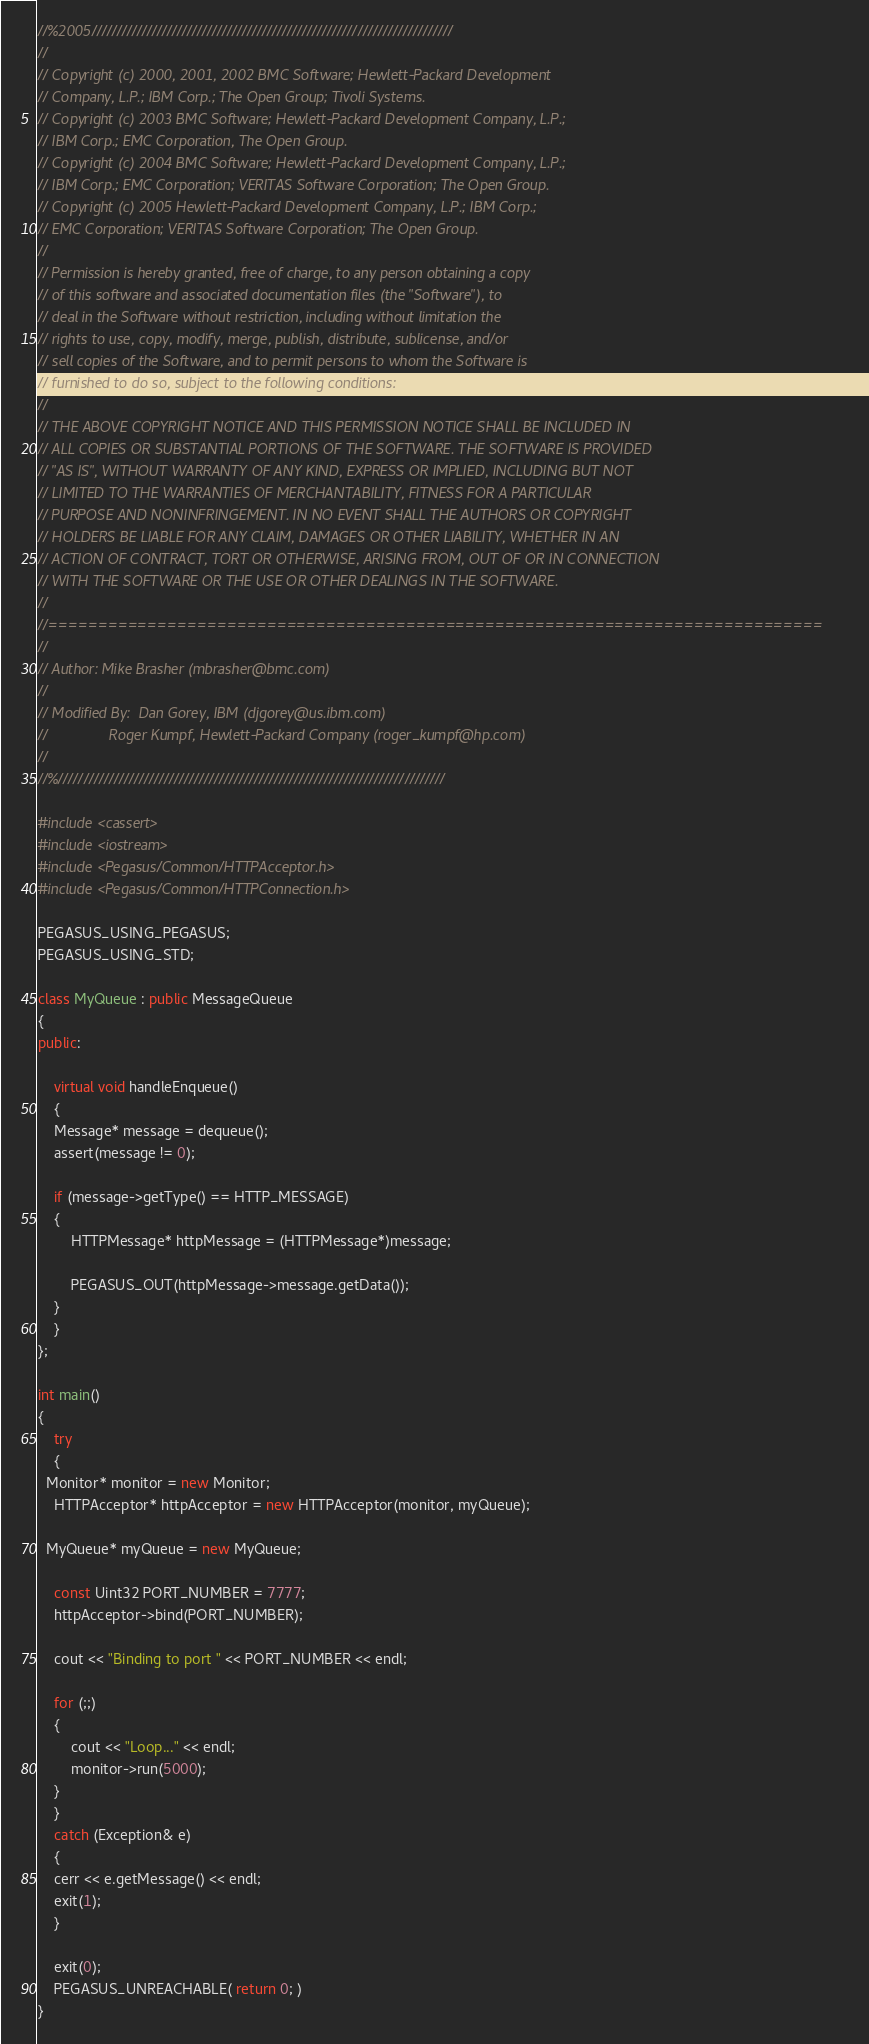<code> <loc_0><loc_0><loc_500><loc_500><_C++_>//%2005////////////////////////////////////////////////////////////////////////
//
// Copyright (c) 2000, 2001, 2002 BMC Software; Hewlett-Packard Development
// Company, L.P.; IBM Corp.; The Open Group; Tivoli Systems.
// Copyright (c) 2003 BMC Software; Hewlett-Packard Development Company, L.P.;
// IBM Corp.; EMC Corporation, The Open Group.
// Copyright (c) 2004 BMC Software; Hewlett-Packard Development Company, L.P.;
// IBM Corp.; EMC Corporation; VERITAS Software Corporation; The Open Group.
// Copyright (c) 2005 Hewlett-Packard Development Company, L.P.; IBM Corp.;
// EMC Corporation; VERITAS Software Corporation; The Open Group.
//
// Permission is hereby granted, free of charge, to any person obtaining a copy
// of this software and associated documentation files (the "Software"), to
// deal in the Software without restriction, including without limitation the
// rights to use, copy, modify, merge, publish, distribute, sublicense, and/or
// sell copies of the Software, and to permit persons to whom the Software is
// furnished to do so, subject to the following conditions:
// 
// THE ABOVE COPYRIGHT NOTICE AND THIS PERMISSION NOTICE SHALL BE INCLUDED IN
// ALL COPIES OR SUBSTANTIAL PORTIONS OF THE SOFTWARE. THE SOFTWARE IS PROVIDED
// "AS IS", WITHOUT WARRANTY OF ANY KIND, EXPRESS OR IMPLIED, INCLUDING BUT NOT
// LIMITED TO THE WARRANTIES OF MERCHANTABILITY, FITNESS FOR A PARTICULAR
// PURPOSE AND NONINFRINGEMENT. IN NO EVENT SHALL THE AUTHORS OR COPYRIGHT
// HOLDERS BE LIABLE FOR ANY CLAIM, DAMAGES OR OTHER LIABILITY, WHETHER IN AN
// ACTION OF CONTRACT, TORT OR OTHERWISE, ARISING FROM, OUT OF OR IN CONNECTION
// WITH THE SOFTWARE OR THE USE OR OTHER DEALINGS IN THE SOFTWARE.
//
//==============================================================================
//
// Author: Mike Brasher (mbrasher@bmc.com)
//
// Modified By:  Dan Gorey, IBM (djgorey@us.ibm.com)
//               Roger Kumpf, Hewlett-Packard Company (roger_kumpf@hp.com)
//
//%/////////////////////////////////////////////////////////////////////////////

#include <cassert>
#include <iostream>
#include <Pegasus/Common/HTTPAcceptor.h>
#include <Pegasus/Common/HTTPConnection.h>

PEGASUS_USING_PEGASUS;
PEGASUS_USING_STD;

class MyQueue : public MessageQueue
{
public:

    virtual void handleEnqueue()
    {
	Message* message = dequeue();
	assert(message != 0);

	if (message->getType() == HTTP_MESSAGE)
	{
	    HTTPMessage* httpMessage = (HTTPMessage*)message;

	    PEGASUS_OUT(httpMessage->message.getData());
	}
    }
};

int main()
{
    try
    {
  Monitor* monitor = new Monitor;
	HTTPAcceptor* httpAcceptor = new HTTPAcceptor(monitor, myQueue);

  MyQueue* myQueue = new MyQueue;

	const Uint32 PORT_NUMBER = 7777;
	httpAcceptor->bind(PORT_NUMBER);

	cout << "Binding to port " << PORT_NUMBER << endl;

	for (;;)
	{
	    cout << "Loop..." << endl;
	    monitor->run(5000);
	}
    }
    catch (Exception& e)
    {
	cerr << e.getMessage() << endl;
	exit(1);
    }

    exit(0);
    PEGASUS_UNREACHABLE( return 0; )
}
</code> 